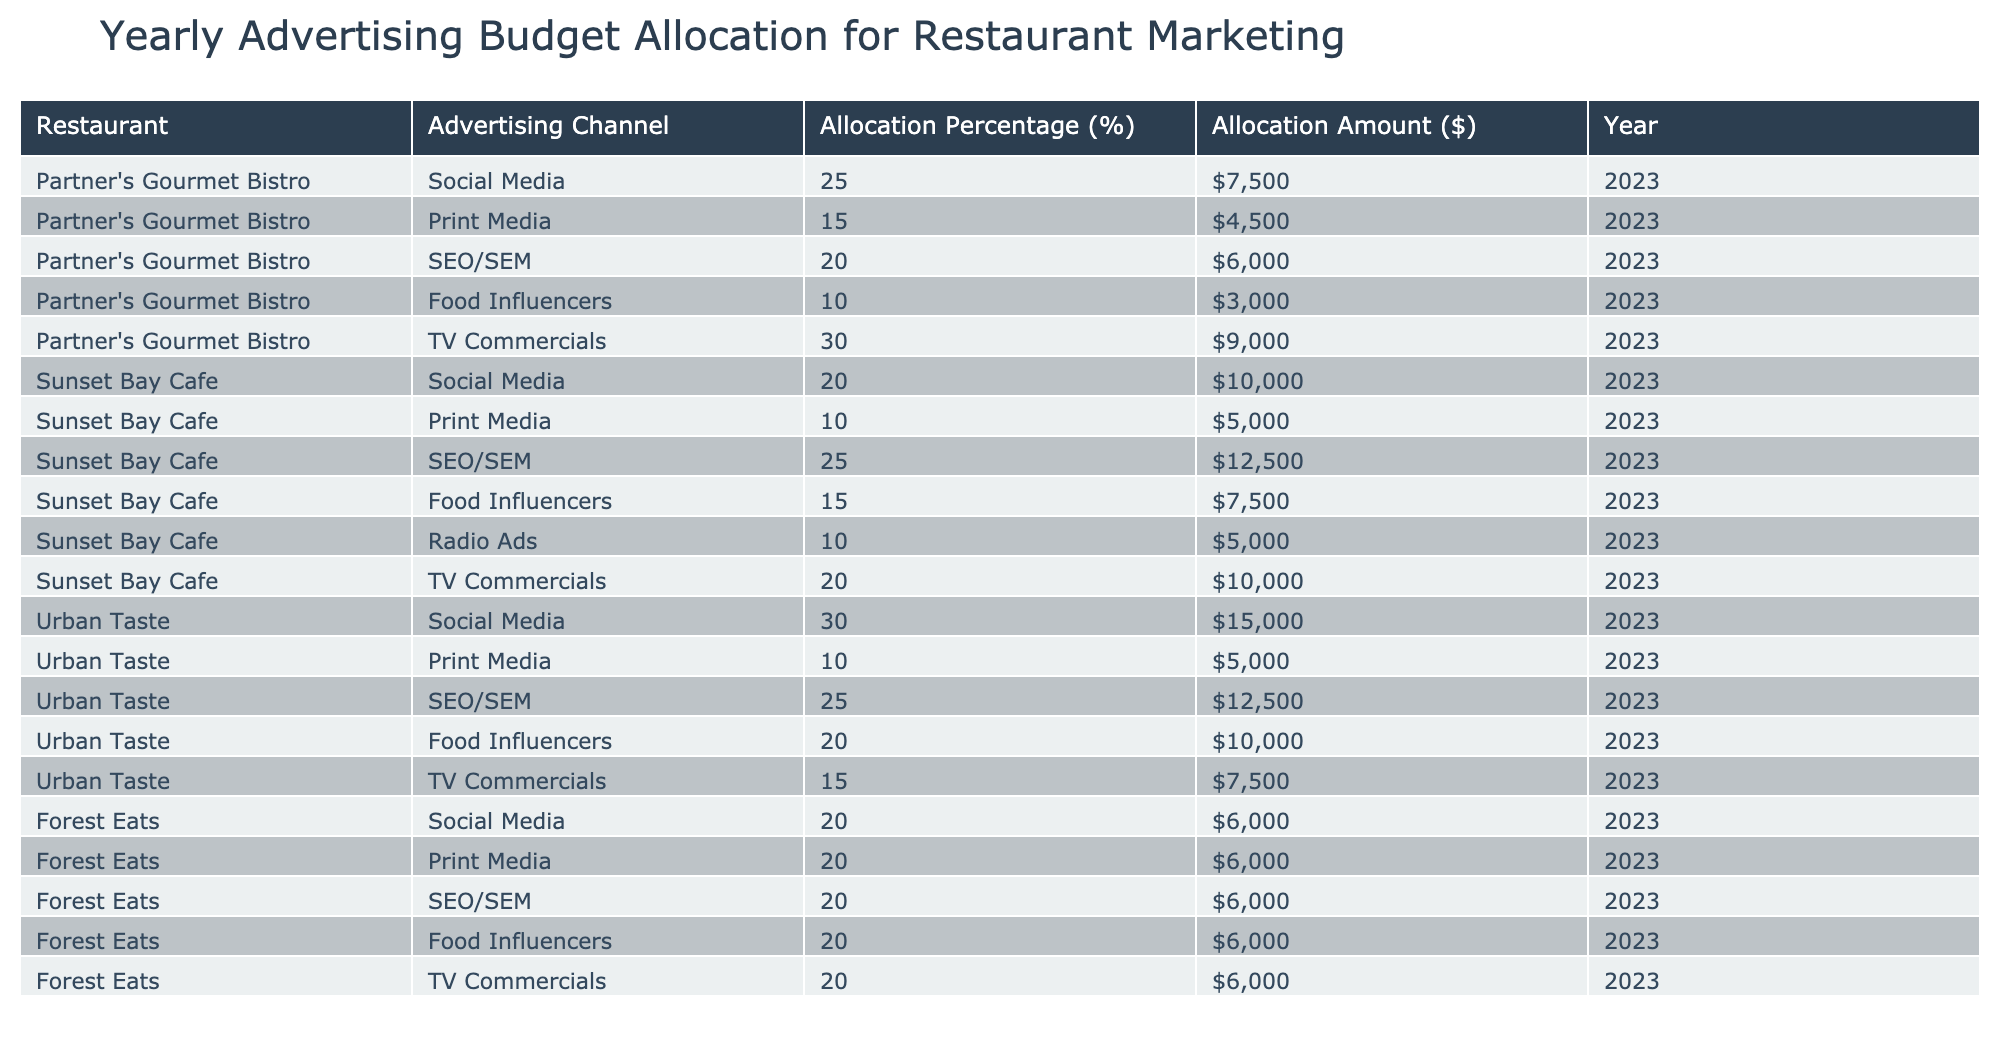What is the total advertising budget for Partner's Gourmet Bistro? To find the total budget, add the allocation amounts for all advertising channels: 7500 + 4500 + 6000 + 3000 + 9000 = 30,000.
Answer: 30,000 Which advertising channel received the highest allocation percentage for Sunset Bay Cafe? By examining the percentages, SEO/SEM has the highest allocation at 25%.
Answer: 25% Did Urban Taste allocate any funds to Print Media? Urban Taste has allocated 10% to Print Media, confirming funds were allocated.
Answer: Yes What is the average allocation amount for Food Influencers across all restaurants? The allocation amounts for Food Influencers are: Partner's Gourmet Bistro (3000), Sunset Bay Cafe (7500), Urban Taste (10000), Forest Eats (6000). Adding these amounts gives 3000 + 7500 + 10000 + 6000 = 30000. There are 4 data points, so the average is 30000/4 = 7500.
Answer: 7500 Which restaurant spent the least on Social Media advertising? Comparing the Social Media allocations: Partner's Gourmet Bistro (7500), Sunset Bay Cafe (10000), Urban Taste (15000), and Forest Eats (6000), Forest Eats spent the least at 6000.
Answer: 6000 